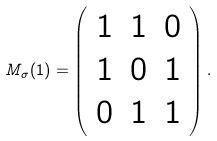<formula> <loc_0><loc_0><loc_500><loc_500>M _ { \sigma } ( 1 ) = \left ( \begin{array} { c c c } 1 & 1 & 0 \\ 1 & 0 & 1 \\ 0 & 1 & 1 \end{array} \right ) .</formula> 